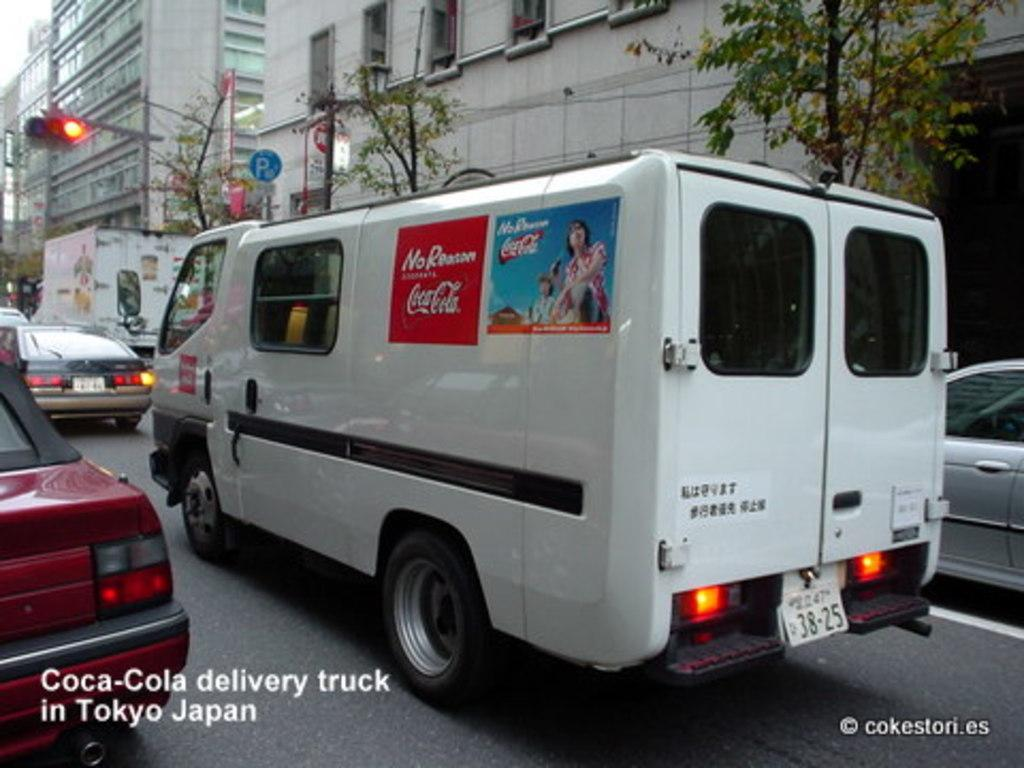<image>
Create a compact narrative representing the image presented. White van with an ad for Coca Cola on it. 